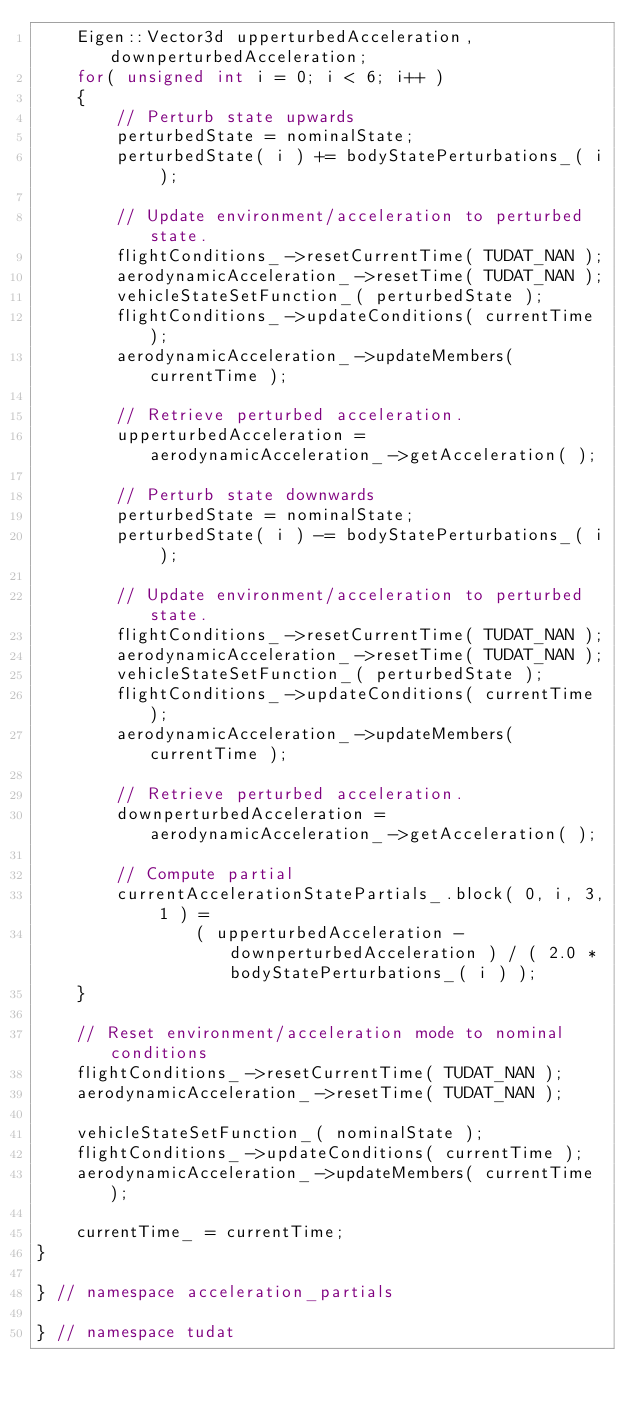<code> <loc_0><loc_0><loc_500><loc_500><_C++_>    Eigen::Vector3d upperturbedAcceleration, downperturbedAcceleration;
    for( unsigned int i = 0; i < 6; i++ )
    {
        // Perturb state upwards
        perturbedState = nominalState;
        perturbedState( i ) += bodyStatePerturbations_( i );

        // Update environment/acceleration to perturbed state.
        flightConditions_->resetCurrentTime( TUDAT_NAN );
        aerodynamicAcceleration_->resetTime( TUDAT_NAN );
        vehicleStateSetFunction_( perturbedState );
        flightConditions_->updateConditions( currentTime );
        aerodynamicAcceleration_->updateMembers( currentTime );

        // Retrieve perturbed acceleration.
        upperturbedAcceleration = aerodynamicAcceleration_->getAcceleration( );

        // Perturb state downwards
        perturbedState = nominalState;
        perturbedState( i ) -= bodyStatePerturbations_( i );

        // Update environment/acceleration to perturbed state.
        flightConditions_->resetCurrentTime( TUDAT_NAN );
        aerodynamicAcceleration_->resetTime( TUDAT_NAN );
        vehicleStateSetFunction_( perturbedState );
        flightConditions_->updateConditions( currentTime );
        aerodynamicAcceleration_->updateMembers( currentTime );

        // Retrieve perturbed acceleration.
        downperturbedAcceleration = aerodynamicAcceleration_->getAcceleration( );

        // Compute partial
        currentAccelerationStatePartials_.block( 0, i, 3, 1 ) =
                ( upperturbedAcceleration - downperturbedAcceleration ) / ( 2.0 * bodyStatePerturbations_( i ) );
    }

    // Reset environment/acceleration mode to nominal conditions
    flightConditions_->resetCurrentTime( TUDAT_NAN );
    aerodynamicAcceleration_->resetTime( TUDAT_NAN );

    vehicleStateSetFunction_( nominalState );
    flightConditions_->updateConditions( currentTime );
    aerodynamicAcceleration_->updateMembers( currentTime );

    currentTime_ = currentTime;
}

} // namespace acceleration_partials

} // namespace tudat
</code> 